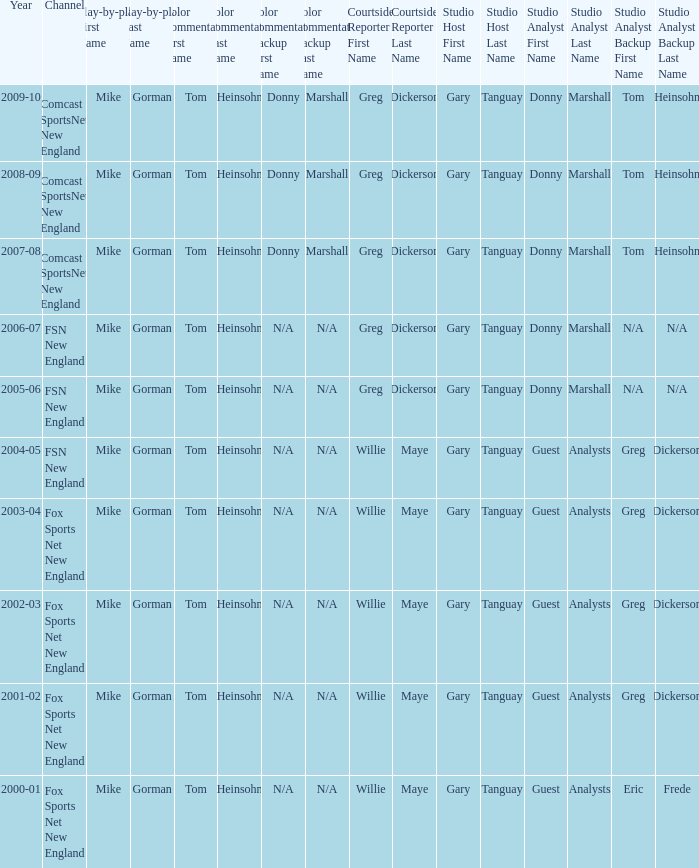Which studio analysts had a studio host named gary tanguay in 2009-10? Donny Marshall or Tom Heinsohn (Select road games). I'm looking to parse the entire table for insights. Could you assist me with that? {'header': ['Year', 'Channel', 'Play-by-play First Name', 'Play-by-play Last Name', 'Color Commentator First Name', 'Color Commentator Last Name', 'Color Commentator Backup First Name', 'Color Commentator Backup Last Name', 'Courtside Reporter First Name', 'Courtside Reporter Last Name', 'Studio Host First Name', 'Studio Host Last Name', 'Studio Analyst First Name', 'Studio Analyst Last Name', 'Studio Analyst Backup First Name', 'Studio Analyst Backup Last Name'], 'rows': [['2009-10', 'Comcast SportsNet New England', 'Mike', 'Gorman', 'Tom', 'Heinsohn', 'Donny', 'Marshall', 'Greg', 'Dickerson', 'Gary', 'Tanguay', 'Donny', 'Marshall', 'Tom', 'Heinsohn'], ['2008-09', 'Comcast SportsNet New England', 'Mike', 'Gorman', 'Tom', 'Heinsohn', 'Donny', 'Marshall', 'Greg', 'Dickerson', 'Gary', 'Tanguay', 'Donny', 'Marshall', 'Tom', 'Heinsohn'], ['2007-08', 'Comcast SportsNet New England', 'Mike', 'Gorman', 'Tom', 'Heinsohn', 'Donny', 'Marshall', 'Greg', 'Dickerson', 'Gary', 'Tanguay', 'Donny', 'Marshall', 'Tom', 'Heinsohn'], ['2006-07', 'FSN New England', 'Mike', 'Gorman', 'Tom', 'Heinsohn', 'N/A', 'N/A', 'Greg', 'Dickerson', 'Gary', 'Tanguay', 'Donny', 'Marshall', 'N/A', 'N/A'], ['2005-06', 'FSN New England', 'Mike', 'Gorman', 'Tom', 'Heinsohn', 'N/A', 'N/A', 'Greg', 'Dickerson', 'Gary', 'Tanguay', 'Donny', 'Marshall', 'N/A', 'N/A'], ['2004-05', 'FSN New England', 'Mike', 'Gorman', 'Tom', 'Heinsohn', 'N/A', 'N/A', 'Willie', 'Maye', 'Gary', 'Tanguay', 'Guest', 'Analysts', 'Greg', 'Dickerson'], ['2003-04', 'Fox Sports Net New England', 'Mike', 'Gorman', 'Tom', 'Heinsohn', 'N/A', 'N/A', 'Willie', 'Maye', 'Gary', 'Tanguay', 'Guest', 'Analysts', 'Greg', 'Dickerson'], ['2002-03', 'Fox Sports Net New England', 'Mike', 'Gorman', 'Tom', 'Heinsohn', 'N/A', 'N/A', 'Willie', 'Maye', 'Gary', 'Tanguay', 'Guest', 'Analysts', 'Greg', 'Dickerson'], ['2001-02', 'Fox Sports Net New England', 'Mike', 'Gorman', 'Tom', 'Heinsohn', 'N/A', 'N/A', 'Willie', 'Maye', 'Gary', 'Tanguay', 'Guest', 'Analysts', 'Greg', 'Dickerson'], ['2000-01', 'Fox Sports Net New England', 'Mike', 'Gorman', 'Tom', 'Heinsohn', 'N/A', 'N/A', 'Willie', 'Maye', 'Gary', 'Tanguay', 'Guest', 'Analysts', 'Eric', 'Frede']]} 